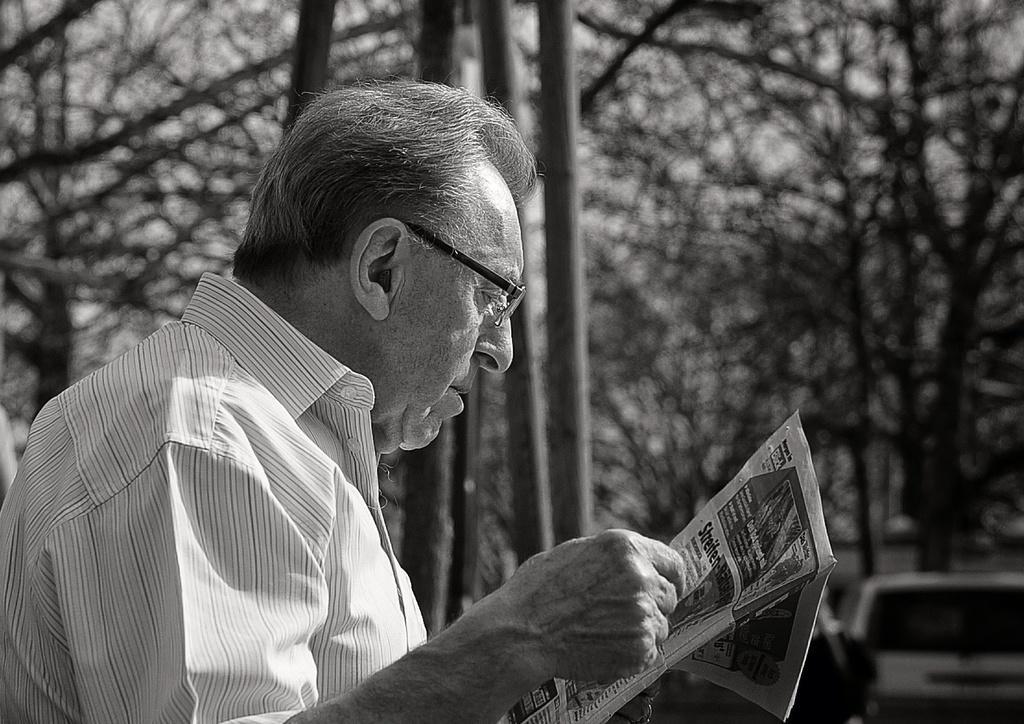Please provide a concise description of this image. In this image we can see a person wearing white color T-shirt and spectacles reading newspaper and at the background of the image there are some trees and a vehicle which is parked. 